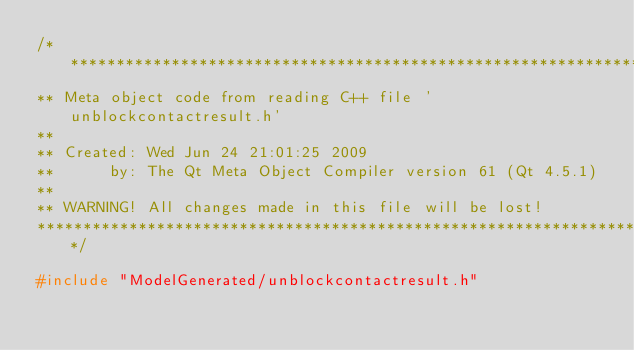Convert code to text. <code><loc_0><loc_0><loc_500><loc_500><_C++_>/****************************************************************************
** Meta object code from reading C++ file 'unblockcontactresult.h'
**
** Created: Wed Jun 24 21:01:25 2009
**      by: The Qt Meta Object Compiler version 61 (Qt 4.5.1)
**
** WARNING! All changes made in this file will be lost!
*****************************************************************************/

#include "ModelGenerated/unblockcontactresult.h"</code> 